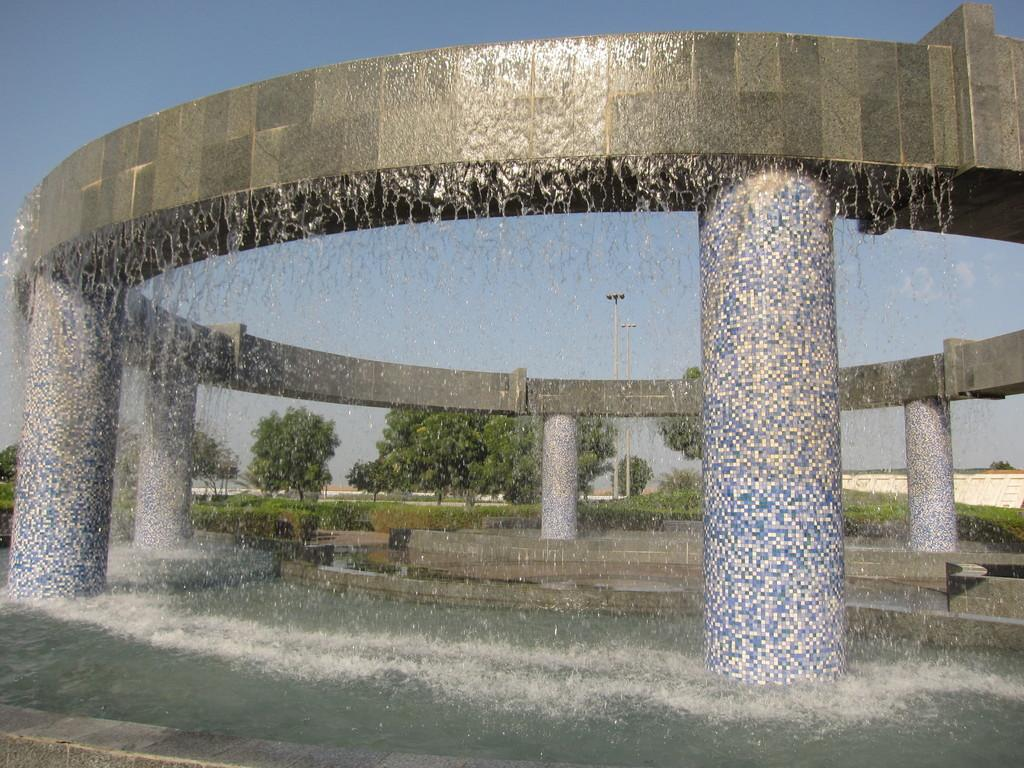What is the main subject in the center of the image? There is a water fountain in the center of the image. What can be seen at the bottom of the image? There is water visible at the bottom of the image. What type of natural scenery is visible in the background of the image? There are trees in the background of the background of the image. What else can be seen in the background of the image? The sky is visible in the background of the image. What type of wood is used to make the stew in the image? There is no stew present in the image, and therefore no wood or cooking is involved. 